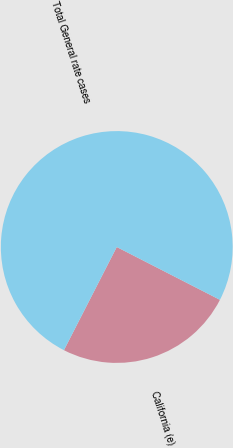Convert chart to OTSL. <chart><loc_0><loc_0><loc_500><loc_500><pie_chart><fcel>California (e)<fcel>Total General rate cases<nl><fcel>25.0%<fcel>75.0%<nl></chart> 